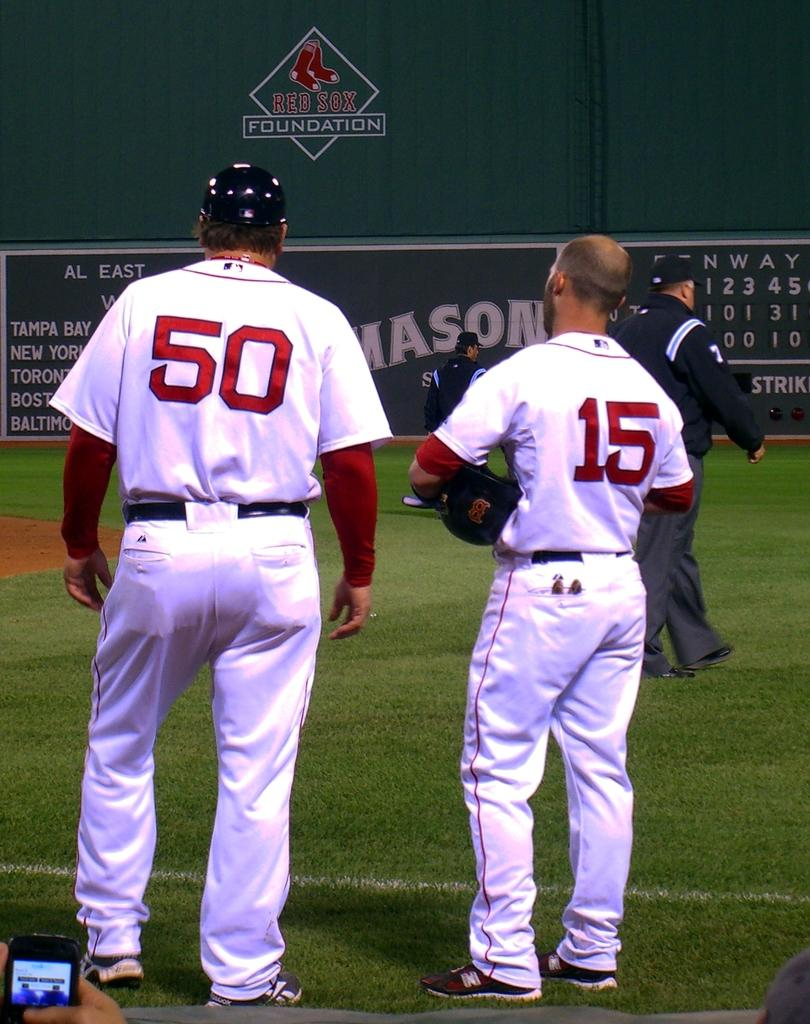<image>
Give a short and clear explanation of the subsequent image. Two ball players stand in front of a wall bearing the Red Sox Foundation logo. 